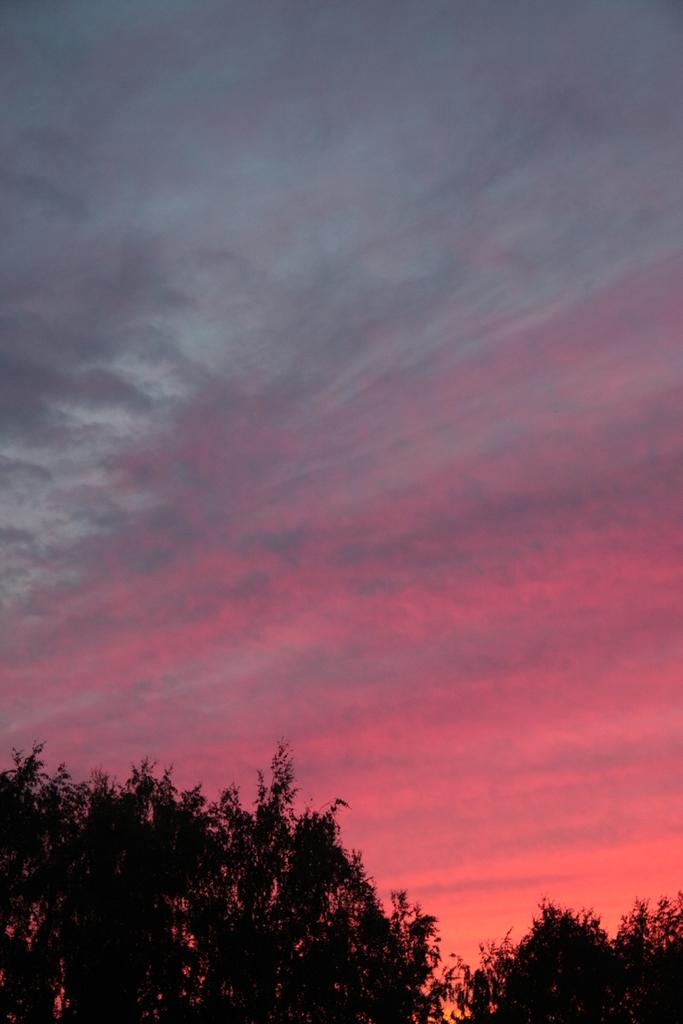What type of vegetation is present at the bottom of the image? There are trees at the bottom of the image. What is the condition of the sky in the image? The sky is cloudy in the image. How does the rat wash its paws in the image? There is no rat present in the image, so it is not possible to answer that question. 